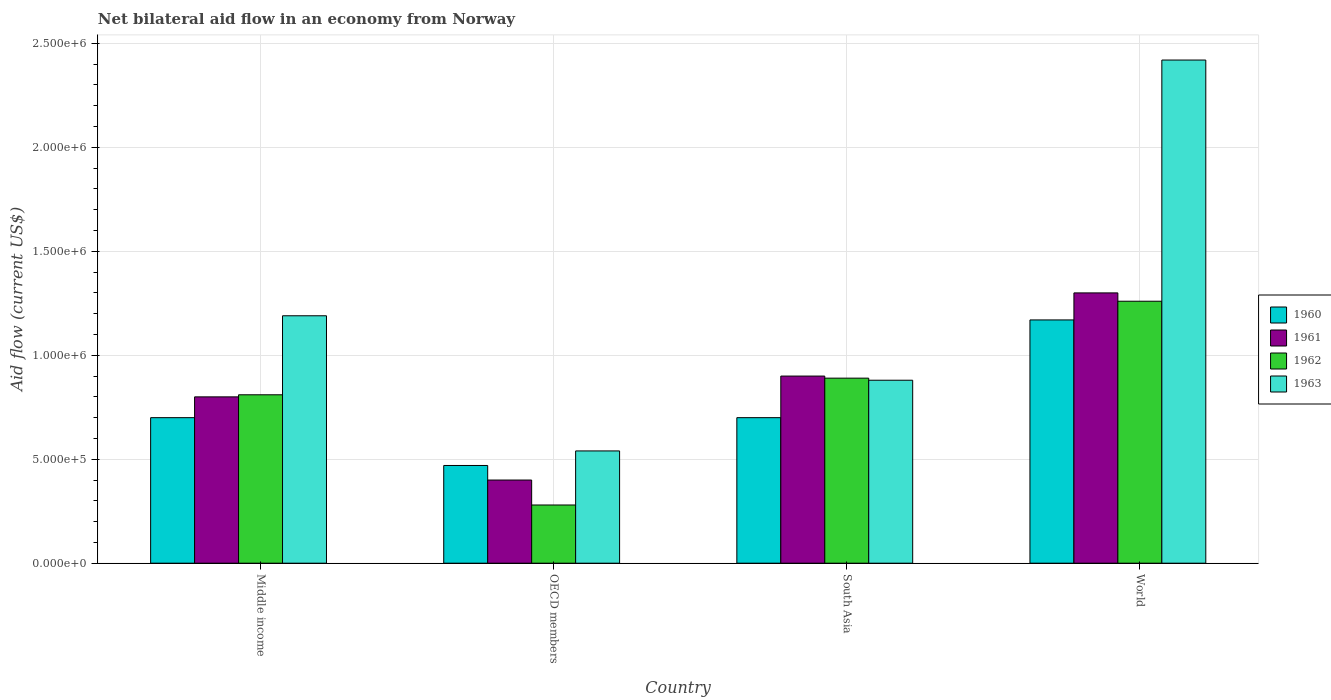How many different coloured bars are there?
Offer a very short reply. 4. Are the number of bars on each tick of the X-axis equal?
Make the answer very short. Yes. What is the label of the 2nd group of bars from the left?
Provide a short and direct response. OECD members. In how many cases, is the number of bars for a given country not equal to the number of legend labels?
Your response must be concise. 0. What is the net bilateral aid flow in 1963 in Middle income?
Your answer should be compact. 1.19e+06. Across all countries, what is the maximum net bilateral aid flow in 1960?
Offer a very short reply. 1.17e+06. Across all countries, what is the minimum net bilateral aid flow in 1960?
Provide a short and direct response. 4.70e+05. What is the total net bilateral aid flow in 1961 in the graph?
Offer a terse response. 3.40e+06. What is the difference between the net bilateral aid flow in 1961 in South Asia and that in World?
Your answer should be very brief. -4.00e+05. What is the difference between the net bilateral aid flow in 1961 in World and the net bilateral aid flow in 1962 in South Asia?
Ensure brevity in your answer.  4.10e+05. What is the average net bilateral aid flow in 1961 per country?
Make the answer very short. 8.50e+05. In how many countries, is the net bilateral aid flow in 1961 greater than 1900000 US$?
Make the answer very short. 0. What is the ratio of the net bilateral aid flow in 1960 in Middle income to that in OECD members?
Keep it short and to the point. 1.49. Is the net bilateral aid flow in 1960 in OECD members less than that in South Asia?
Give a very brief answer. Yes. What is the difference between the highest and the second highest net bilateral aid flow in 1963?
Provide a short and direct response. 1.23e+06. What is the difference between the highest and the lowest net bilateral aid flow in 1960?
Your answer should be compact. 7.00e+05. Is the sum of the net bilateral aid flow in 1962 in Middle income and OECD members greater than the maximum net bilateral aid flow in 1963 across all countries?
Your answer should be compact. No. What does the 3rd bar from the right in Middle income represents?
Your response must be concise. 1961. How many countries are there in the graph?
Give a very brief answer. 4. Does the graph contain any zero values?
Ensure brevity in your answer.  No. Does the graph contain grids?
Your answer should be compact. Yes. Where does the legend appear in the graph?
Make the answer very short. Center right. What is the title of the graph?
Give a very brief answer. Net bilateral aid flow in an economy from Norway. Does "2003" appear as one of the legend labels in the graph?
Your answer should be compact. No. What is the label or title of the X-axis?
Your answer should be compact. Country. What is the Aid flow (current US$) in 1962 in Middle income?
Your response must be concise. 8.10e+05. What is the Aid flow (current US$) of 1963 in Middle income?
Ensure brevity in your answer.  1.19e+06. What is the Aid flow (current US$) of 1960 in OECD members?
Ensure brevity in your answer.  4.70e+05. What is the Aid flow (current US$) in 1961 in OECD members?
Keep it short and to the point. 4.00e+05. What is the Aid flow (current US$) in 1962 in OECD members?
Provide a short and direct response. 2.80e+05. What is the Aid flow (current US$) in 1963 in OECD members?
Offer a terse response. 5.40e+05. What is the Aid flow (current US$) in 1962 in South Asia?
Your response must be concise. 8.90e+05. What is the Aid flow (current US$) in 1963 in South Asia?
Ensure brevity in your answer.  8.80e+05. What is the Aid flow (current US$) in 1960 in World?
Your answer should be very brief. 1.17e+06. What is the Aid flow (current US$) of 1961 in World?
Offer a very short reply. 1.30e+06. What is the Aid flow (current US$) of 1962 in World?
Make the answer very short. 1.26e+06. What is the Aid flow (current US$) in 1963 in World?
Provide a short and direct response. 2.42e+06. Across all countries, what is the maximum Aid flow (current US$) of 1960?
Ensure brevity in your answer.  1.17e+06. Across all countries, what is the maximum Aid flow (current US$) in 1961?
Offer a terse response. 1.30e+06. Across all countries, what is the maximum Aid flow (current US$) of 1962?
Ensure brevity in your answer.  1.26e+06. Across all countries, what is the maximum Aid flow (current US$) in 1963?
Ensure brevity in your answer.  2.42e+06. Across all countries, what is the minimum Aid flow (current US$) of 1960?
Your response must be concise. 4.70e+05. Across all countries, what is the minimum Aid flow (current US$) of 1963?
Provide a short and direct response. 5.40e+05. What is the total Aid flow (current US$) of 1960 in the graph?
Provide a succinct answer. 3.04e+06. What is the total Aid flow (current US$) of 1961 in the graph?
Give a very brief answer. 3.40e+06. What is the total Aid flow (current US$) of 1962 in the graph?
Offer a terse response. 3.24e+06. What is the total Aid flow (current US$) in 1963 in the graph?
Provide a succinct answer. 5.03e+06. What is the difference between the Aid flow (current US$) in 1962 in Middle income and that in OECD members?
Ensure brevity in your answer.  5.30e+05. What is the difference between the Aid flow (current US$) in 1963 in Middle income and that in OECD members?
Offer a terse response. 6.50e+05. What is the difference between the Aid flow (current US$) of 1960 in Middle income and that in South Asia?
Your answer should be compact. 0. What is the difference between the Aid flow (current US$) of 1962 in Middle income and that in South Asia?
Your response must be concise. -8.00e+04. What is the difference between the Aid flow (current US$) of 1960 in Middle income and that in World?
Offer a very short reply. -4.70e+05. What is the difference between the Aid flow (current US$) of 1961 in Middle income and that in World?
Provide a short and direct response. -5.00e+05. What is the difference between the Aid flow (current US$) in 1962 in Middle income and that in World?
Make the answer very short. -4.50e+05. What is the difference between the Aid flow (current US$) in 1963 in Middle income and that in World?
Your answer should be very brief. -1.23e+06. What is the difference between the Aid flow (current US$) in 1960 in OECD members and that in South Asia?
Keep it short and to the point. -2.30e+05. What is the difference between the Aid flow (current US$) of 1961 in OECD members and that in South Asia?
Provide a short and direct response. -5.00e+05. What is the difference between the Aid flow (current US$) in 1962 in OECD members and that in South Asia?
Give a very brief answer. -6.10e+05. What is the difference between the Aid flow (current US$) in 1963 in OECD members and that in South Asia?
Your answer should be very brief. -3.40e+05. What is the difference between the Aid flow (current US$) of 1960 in OECD members and that in World?
Provide a succinct answer. -7.00e+05. What is the difference between the Aid flow (current US$) of 1961 in OECD members and that in World?
Your answer should be compact. -9.00e+05. What is the difference between the Aid flow (current US$) of 1962 in OECD members and that in World?
Keep it short and to the point. -9.80e+05. What is the difference between the Aid flow (current US$) in 1963 in OECD members and that in World?
Give a very brief answer. -1.88e+06. What is the difference between the Aid flow (current US$) of 1960 in South Asia and that in World?
Offer a terse response. -4.70e+05. What is the difference between the Aid flow (current US$) in 1961 in South Asia and that in World?
Your response must be concise. -4.00e+05. What is the difference between the Aid flow (current US$) in 1962 in South Asia and that in World?
Give a very brief answer. -3.70e+05. What is the difference between the Aid flow (current US$) of 1963 in South Asia and that in World?
Provide a succinct answer. -1.54e+06. What is the difference between the Aid flow (current US$) of 1960 in Middle income and the Aid flow (current US$) of 1962 in OECD members?
Give a very brief answer. 4.20e+05. What is the difference between the Aid flow (current US$) of 1961 in Middle income and the Aid flow (current US$) of 1962 in OECD members?
Provide a short and direct response. 5.20e+05. What is the difference between the Aid flow (current US$) in 1961 in Middle income and the Aid flow (current US$) in 1963 in OECD members?
Keep it short and to the point. 2.60e+05. What is the difference between the Aid flow (current US$) in 1962 in Middle income and the Aid flow (current US$) in 1963 in OECD members?
Your response must be concise. 2.70e+05. What is the difference between the Aid flow (current US$) of 1960 in Middle income and the Aid flow (current US$) of 1962 in South Asia?
Offer a very short reply. -1.90e+05. What is the difference between the Aid flow (current US$) of 1960 in Middle income and the Aid flow (current US$) of 1963 in South Asia?
Your answer should be compact. -1.80e+05. What is the difference between the Aid flow (current US$) of 1962 in Middle income and the Aid flow (current US$) of 1963 in South Asia?
Your answer should be compact. -7.00e+04. What is the difference between the Aid flow (current US$) of 1960 in Middle income and the Aid flow (current US$) of 1961 in World?
Give a very brief answer. -6.00e+05. What is the difference between the Aid flow (current US$) in 1960 in Middle income and the Aid flow (current US$) in 1962 in World?
Make the answer very short. -5.60e+05. What is the difference between the Aid flow (current US$) of 1960 in Middle income and the Aid flow (current US$) of 1963 in World?
Ensure brevity in your answer.  -1.72e+06. What is the difference between the Aid flow (current US$) in 1961 in Middle income and the Aid flow (current US$) in 1962 in World?
Your answer should be very brief. -4.60e+05. What is the difference between the Aid flow (current US$) in 1961 in Middle income and the Aid flow (current US$) in 1963 in World?
Make the answer very short. -1.62e+06. What is the difference between the Aid flow (current US$) of 1962 in Middle income and the Aid flow (current US$) of 1963 in World?
Keep it short and to the point. -1.61e+06. What is the difference between the Aid flow (current US$) of 1960 in OECD members and the Aid flow (current US$) of 1961 in South Asia?
Offer a very short reply. -4.30e+05. What is the difference between the Aid flow (current US$) of 1960 in OECD members and the Aid flow (current US$) of 1962 in South Asia?
Keep it short and to the point. -4.20e+05. What is the difference between the Aid flow (current US$) of 1960 in OECD members and the Aid flow (current US$) of 1963 in South Asia?
Give a very brief answer. -4.10e+05. What is the difference between the Aid flow (current US$) of 1961 in OECD members and the Aid flow (current US$) of 1962 in South Asia?
Give a very brief answer. -4.90e+05. What is the difference between the Aid flow (current US$) of 1961 in OECD members and the Aid flow (current US$) of 1963 in South Asia?
Your response must be concise. -4.80e+05. What is the difference between the Aid flow (current US$) in 1962 in OECD members and the Aid flow (current US$) in 1963 in South Asia?
Ensure brevity in your answer.  -6.00e+05. What is the difference between the Aid flow (current US$) of 1960 in OECD members and the Aid flow (current US$) of 1961 in World?
Your response must be concise. -8.30e+05. What is the difference between the Aid flow (current US$) in 1960 in OECD members and the Aid flow (current US$) in 1962 in World?
Your response must be concise. -7.90e+05. What is the difference between the Aid flow (current US$) in 1960 in OECD members and the Aid flow (current US$) in 1963 in World?
Ensure brevity in your answer.  -1.95e+06. What is the difference between the Aid flow (current US$) in 1961 in OECD members and the Aid flow (current US$) in 1962 in World?
Keep it short and to the point. -8.60e+05. What is the difference between the Aid flow (current US$) in 1961 in OECD members and the Aid flow (current US$) in 1963 in World?
Give a very brief answer. -2.02e+06. What is the difference between the Aid flow (current US$) of 1962 in OECD members and the Aid flow (current US$) of 1963 in World?
Offer a very short reply. -2.14e+06. What is the difference between the Aid flow (current US$) of 1960 in South Asia and the Aid flow (current US$) of 1961 in World?
Offer a terse response. -6.00e+05. What is the difference between the Aid flow (current US$) of 1960 in South Asia and the Aid flow (current US$) of 1962 in World?
Ensure brevity in your answer.  -5.60e+05. What is the difference between the Aid flow (current US$) in 1960 in South Asia and the Aid flow (current US$) in 1963 in World?
Provide a succinct answer. -1.72e+06. What is the difference between the Aid flow (current US$) in 1961 in South Asia and the Aid flow (current US$) in 1962 in World?
Keep it short and to the point. -3.60e+05. What is the difference between the Aid flow (current US$) of 1961 in South Asia and the Aid flow (current US$) of 1963 in World?
Provide a short and direct response. -1.52e+06. What is the difference between the Aid flow (current US$) in 1962 in South Asia and the Aid flow (current US$) in 1963 in World?
Provide a short and direct response. -1.53e+06. What is the average Aid flow (current US$) of 1960 per country?
Your answer should be compact. 7.60e+05. What is the average Aid flow (current US$) of 1961 per country?
Offer a very short reply. 8.50e+05. What is the average Aid flow (current US$) of 1962 per country?
Give a very brief answer. 8.10e+05. What is the average Aid flow (current US$) in 1963 per country?
Offer a very short reply. 1.26e+06. What is the difference between the Aid flow (current US$) in 1960 and Aid flow (current US$) in 1961 in Middle income?
Ensure brevity in your answer.  -1.00e+05. What is the difference between the Aid flow (current US$) of 1960 and Aid flow (current US$) of 1962 in Middle income?
Provide a short and direct response. -1.10e+05. What is the difference between the Aid flow (current US$) in 1960 and Aid flow (current US$) in 1963 in Middle income?
Your answer should be compact. -4.90e+05. What is the difference between the Aid flow (current US$) in 1961 and Aid flow (current US$) in 1962 in Middle income?
Keep it short and to the point. -10000. What is the difference between the Aid flow (current US$) of 1961 and Aid flow (current US$) of 1963 in Middle income?
Provide a succinct answer. -3.90e+05. What is the difference between the Aid flow (current US$) of 1962 and Aid flow (current US$) of 1963 in Middle income?
Your response must be concise. -3.80e+05. What is the difference between the Aid flow (current US$) in 1960 and Aid flow (current US$) in 1961 in OECD members?
Your answer should be compact. 7.00e+04. What is the difference between the Aid flow (current US$) in 1960 and Aid flow (current US$) in 1962 in OECD members?
Your response must be concise. 1.90e+05. What is the difference between the Aid flow (current US$) in 1961 and Aid flow (current US$) in 1962 in OECD members?
Offer a very short reply. 1.20e+05. What is the difference between the Aid flow (current US$) in 1961 and Aid flow (current US$) in 1963 in OECD members?
Provide a succinct answer. -1.40e+05. What is the difference between the Aid flow (current US$) of 1961 and Aid flow (current US$) of 1963 in South Asia?
Your answer should be compact. 2.00e+04. What is the difference between the Aid flow (current US$) of 1960 and Aid flow (current US$) of 1962 in World?
Ensure brevity in your answer.  -9.00e+04. What is the difference between the Aid flow (current US$) of 1960 and Aid flow (current US$) of 1963 in World?
Your answer should be compact. -1.25e+06. What is the difference between the Aid flow (current US$) of 1961 and Aid flow (current US$) of 1963 in World?
Provide a succinct answer. -1.12e+06. What is the difference between the Aid flow (current US$) of 1962 and Aid flow (current US$) of 1963 in World?
Ensure brevity in your answer.  -1.16e+06. What is the ratio of the Aid flow (current US$) of 1960 in Middle income to that in OECD members?
Offer a very short reply. 1.49. What is the ratio of the Aid flow (current US$) in 1962 in Middle income to that in OECD members?
Your answer should be compact. 2.89. What is the ratio of the Aid flow (current US$) of 1963 in Middle income to that in OECD members?
Give a very brief answer. 2.2. What is the ratio of the Aid flow (current US$) of 1961 in Middle income to that in South Asia?
Your answer should be very brief. 0.89. What is the ratio of the Aid flow (current US$) of 1962 in Middle income to that in South Asia?
Your answer should be very brief. 0.91. What is the ratio of the Aid flow (current US$) of 1963 in Middle income to that in South Asia?
Provide a short and direct response. 1.35. What is the ratio of the Aid flow (current US$) of 1960 in Middle income to that in World?
Provide a succinct answer. 0.6. What is the ratio of the Aid flow (current US$) in 1961 in Middle income to that in World?
Provide a succinct answer. 0.62. What is the ratio of the Aid flow (current US$) in 1962 in Middle income to that in World?
Offer a very short reply. 0.64. What is the ratio of the Aid flow (current US$) in 1963 in Middle income to that in World?
Make the answer very short. 0.49. What is the ratio of the Aid flow (current US$) in 1960 in OECD members to that in South Asia?
Provide a succinct answer. 0.67. What is the ratio of the Aid flow (current US$) in 1961 in OECD members to that in South Asia?
Keep it short and to the point. 0.44. What is the ratio of the Aid flow (current US$) in 1962 in OECD members to that in South Asia?
Offer a terse response. 0.31. What is the ratio of the Aid flow (current US$) of 1963 in OECD members to that in South Asia?
Keep it short and to the point. 0.61. What is the ratio of the Aid flow (current US$) of 1960 in OECD members to that in World?
Give a very brief answer. 0.4. What is the ratio of the Aid flow (current US$) of 1961 in OECD members to that in World?
Your answer should be compact. 0.31. What is the ratio of the Aid flow (current US$) of 1962 in OECD members to that in World?
Ensure brevity in your answer.  0.22. What is the ratio of the Aid flow (current US$) of 1963 in OECD members to that in World?
Offer a terse response. 0.22. What is the ratio of the Aid flow (current US$) of 1960 in South Asia to that in World?
Keep it short and to the point. 0.6. What is the ratio of the Aid flow (current US$) in 1961 in South Asia to that in World?
Your response must be concise. 0.69. What is the ratio of the Aid flow (current US$) in 1962 in South Asia to that in World?
Offer a very short reply. 0.71. What is the ratio of the Aid flow (current US$) of 1963 in South Asia to that in World?
Your answer should be compact. 0.36. What is the difference between the highest and the second highest Aid flow (current US$) in 1961?
Provide a succinct answer. 4.00e+05. What is the difference between the highest and the second highest Aid flow (current US$) in 1962?
Offer a terse response. 3.70e+05. What is the difference between the highest and the second highest Aid flow (current US$) in 1963?
Your response must be concise. 1.23e+06. What is the difference between the highest and the lowest Aid flow (current US$) in 1960?
Your response must be concise. 7.00e+05. What is the difference between the highest and the lowest Aid flow (current US$) of 1962?
Provide a short and direct response. 9.80e+05. What is the difference between the highest and the lowest Aid flow (current US$) in 1963?
Provide a succinct answer. 1.88e+06. 